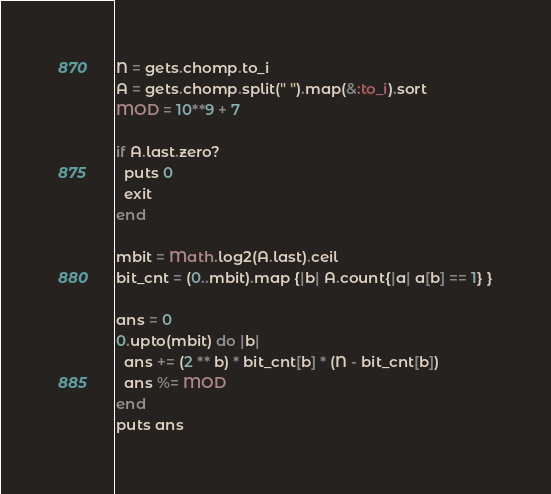Convert code to text. <code><loc_0><loc_0><loc_500><loc_500><_Ruby_>N = gets.chomp.to_i
A = gets.chomp.split(" ").map(&:to_i).sort
MOD = 10**9 + 7

if A.last.zero?
  puts 0
  exit
end

mbit = Math.log2(A.last).ceil
bit_cnt = (0..mbit).map {|b| A.count{|a| a[b] == 1} }

ans = 0
0.upto(mbit) do |b|
  ans += (2 ** b) * bit_cnt[b] * (N - bit_cnt[b])
  ans %= MOD
end
puts ans
</code> 